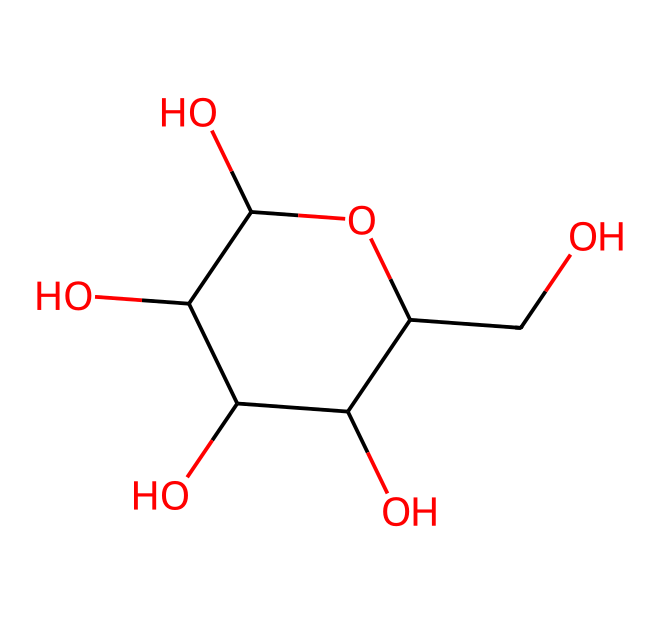How many carbon atoms are in this molecule? To determine the number of carbon atoms, we can analyze the SMILES representation. The 'C' denotes carbon, and counting all the 'C's in the representation yields a total of six carbon atoms.
Answer: six What is the molecular formula of this compound? The molecular formula can be derived by counting the number of each type of atom in the compound based on the SMILES string. The atoms counted are: C - 6, H - 12, and O - 6, resulting in the molecular formula C6H12O6.
Answer: C6H12O6 Does this compound contain any rings? The presence of parentheses in the SMILES indicates the structure includes one or more ringed systems. By analyzing the structure, we can see there is one ring (C1...O1) present.
Answer: yes What functional groups are present in this molecule? In the provided SMILES, we identify the hydroxyl (–OH) groups from the presence of the 'O' connected to carbon atoms. There are multiple –OH groups indicating this is a sugar alcohol, specifically glucose.
Answer: hydroxyl groups Is this molecule a carbohydrate? Considering the molecular structure and functional groups present, this compound fits the definition of a carbohydrate since it is a sugar (specifically glucose) due to its multiple hydroxyl groups and ring structure.
Answer: yes What type of isomerism can occur with this compound? Given the presence of multiple chiral centers (the carbon atoms connected to multiple –OH groups), this compound can exhibit stereoisomerism due to the different spatial arrangements of these chiral centers.
Answer: stereoisomerism What role could this compound play in sports drinks? Given its biochemical structure, this compound acts as a quick source of energy due to its carbohydrate nature, making it valuable for hydration and performance in sports drinks.
Answer: energy source 